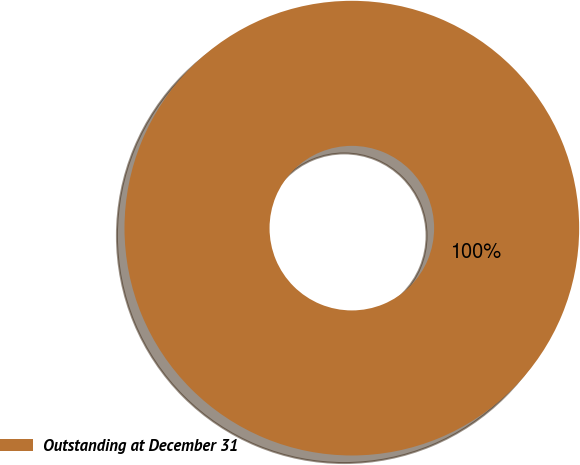Convert chart to OTSL. <chart><loc_0><loc_0><loc_500><loc_500><pie_chart><fcel>Outstanding at December 31<nl><fcel>100.0%<nl></chart> 